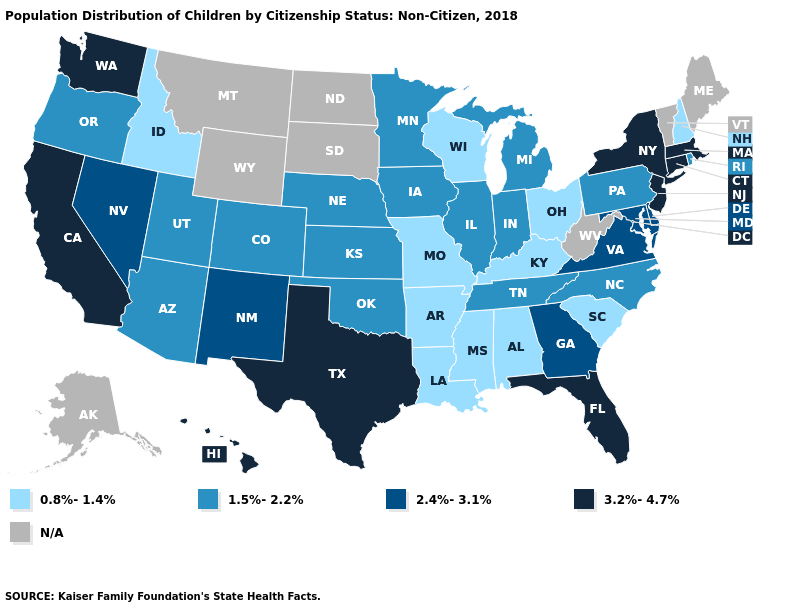Does the map have missing data?
Be succinct. Yes. What is the value of Florida?
Concise answer only. 3.2%-4.7%. Does South Carolina have the lowest value in the USA?
Keep it brief. Yes. Does the map have missing data?
Write a very short answer. Yes. What is the lowest value in the West?
Quick response, please. 0.8%-1.4%. Name the states that have a value in the range 0.8%-1.4%?
Concise answer only. Alabama, Arkansas, Idaho, Kentucky, Louisiana, Mississippi, Missouri, New Hampshire, Ohio, South Carolina, Wisconsin. Name the states that have a value in the range N/A?
Be succinct. Alaska, Maine, Montana, North Dakota, South Dakota, Vermont, West Virginia, Wyoming. What is the value of Georgia?
Give a very brief answer. 2.4%-3.1%. What is the lowest value in the USA?
Concise answer only. 0.8%-1.4%. Does Texas have the highest value in the South?
Give a very brief answer. Yes. How many symbols are there in the legend?
Short answer required. 5. Does Missouri have the highest value in the USA?
Write a very short answer. No. What is the value of Delaware?
Write a very short answer. 2.4%-3.1%. 